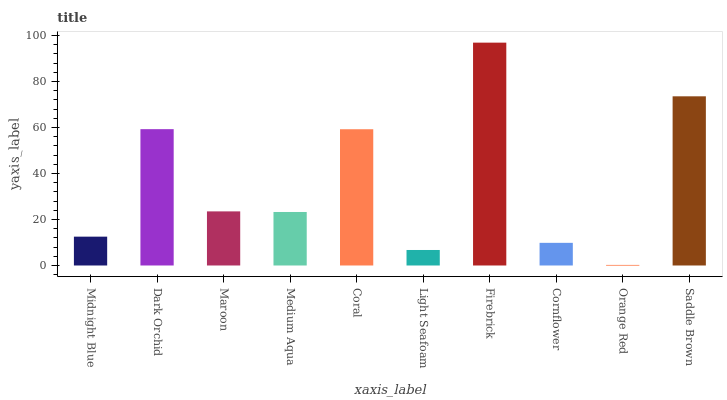Is Orange Red the minimum?
Answer yes or no. Yes. Is Firebrick the maximum?
Answer yes or no. Yes. Is Dark Orchid the minimum?
Answer yes or no. No. Is Dark Orchid the maximum?
Answer yes or no. No. Is Dark Orchid greater than Midnight Blue?
Answer yes or no. Yes. Is Midnight Blue less than Dark Orchid?
Answer yes or no. Yes. Is Midnight Blue greater than Dark Orchid?
Answer yes or no. No. Is Dark Orchid less than Midnight Blue?
Answer yes or no. No. Is Maroon the high median?
Answer yes or no. Yes. Is Medium Aqua the low median?
Answer yes or no. Yes. Is Firebrick the high median?
Answer yes or no. No. Is Saddle Brown the low median?
Answer yes or no. No. 